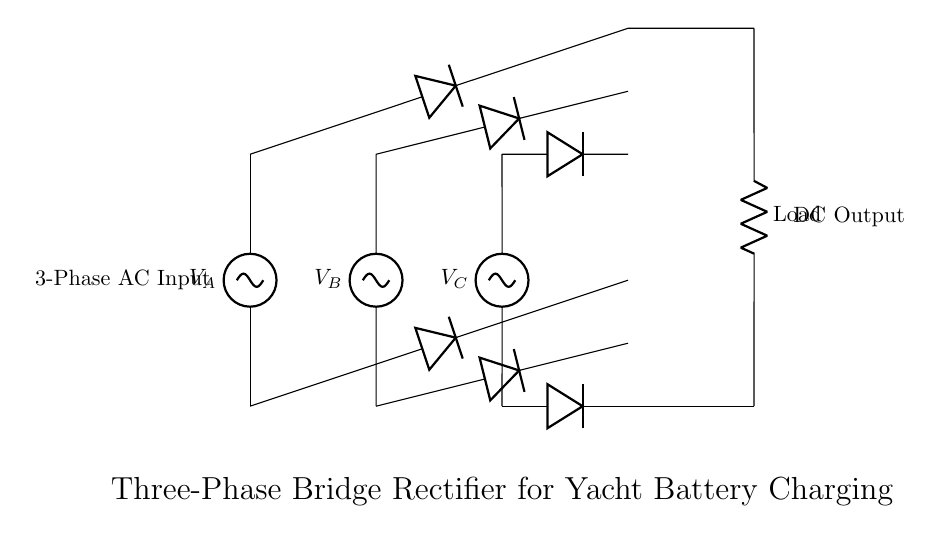What type of circuit is this? This circuit is a three-phase bridge rectifier, which consists of diodes arranged in a bridge configuration to convert three-phase AC power to DC.
Answer: three-phase bridge rectifier What are the main components used in this circuit? The main components are three diodes connecting the AC inputs and three diodes that connect to the DC output, creating a bridge rectifier structure.
Answer: diodes How many AC voltage sources are present? There are three AC voltage sources labeled as V_A, V_B, and V_C in the diagram, which supply the alternating current to the rectifier.
Answer: three What is the output of this circuit? The output of this circuit is a direct current (DC), which can be utilized to charge yacht batteries or supply DC power to various yacht systems.
Answer: DC What is the function of the load resistor? The load resistor in the circuit represents the component that consumes the rectified DC power, which can be referred to as the load for the battery charging.
Answer: load Why are there six diodes in this rectifier configuration? There are six diodes because this is a three-phase bridge rectifier where each phase voltage is handled by two diodes (forward and reverse), allowing for effective conversion of three-phase AC to DC.
Answer: six What kind of power does this circuit convert? This circuit converts three-phase alternating current (AC) shore power into direct current (DC) for battery charging.
Answer: alternating current 